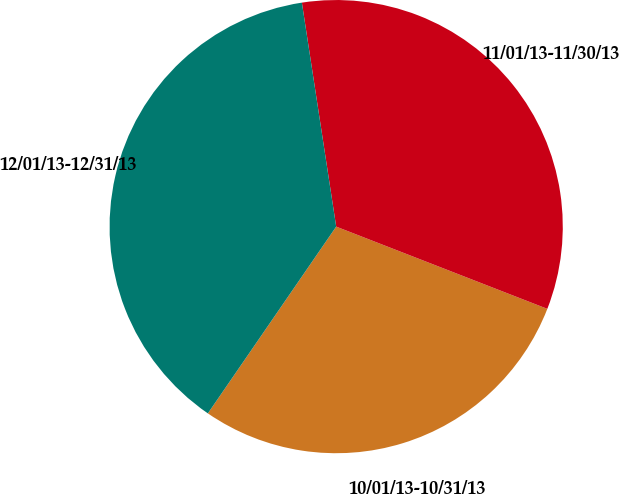<chart> <loc_0><loc_0><loc_500><loc_500><pie_chart><fcel>10/01/13-10/31/13<fcel>11/01/13-11/30/13<fcel>12/01/13-12/31/13<nl><fcel>28.67%<fcel>33.33%<fcel>38.0%<nl></chart> 